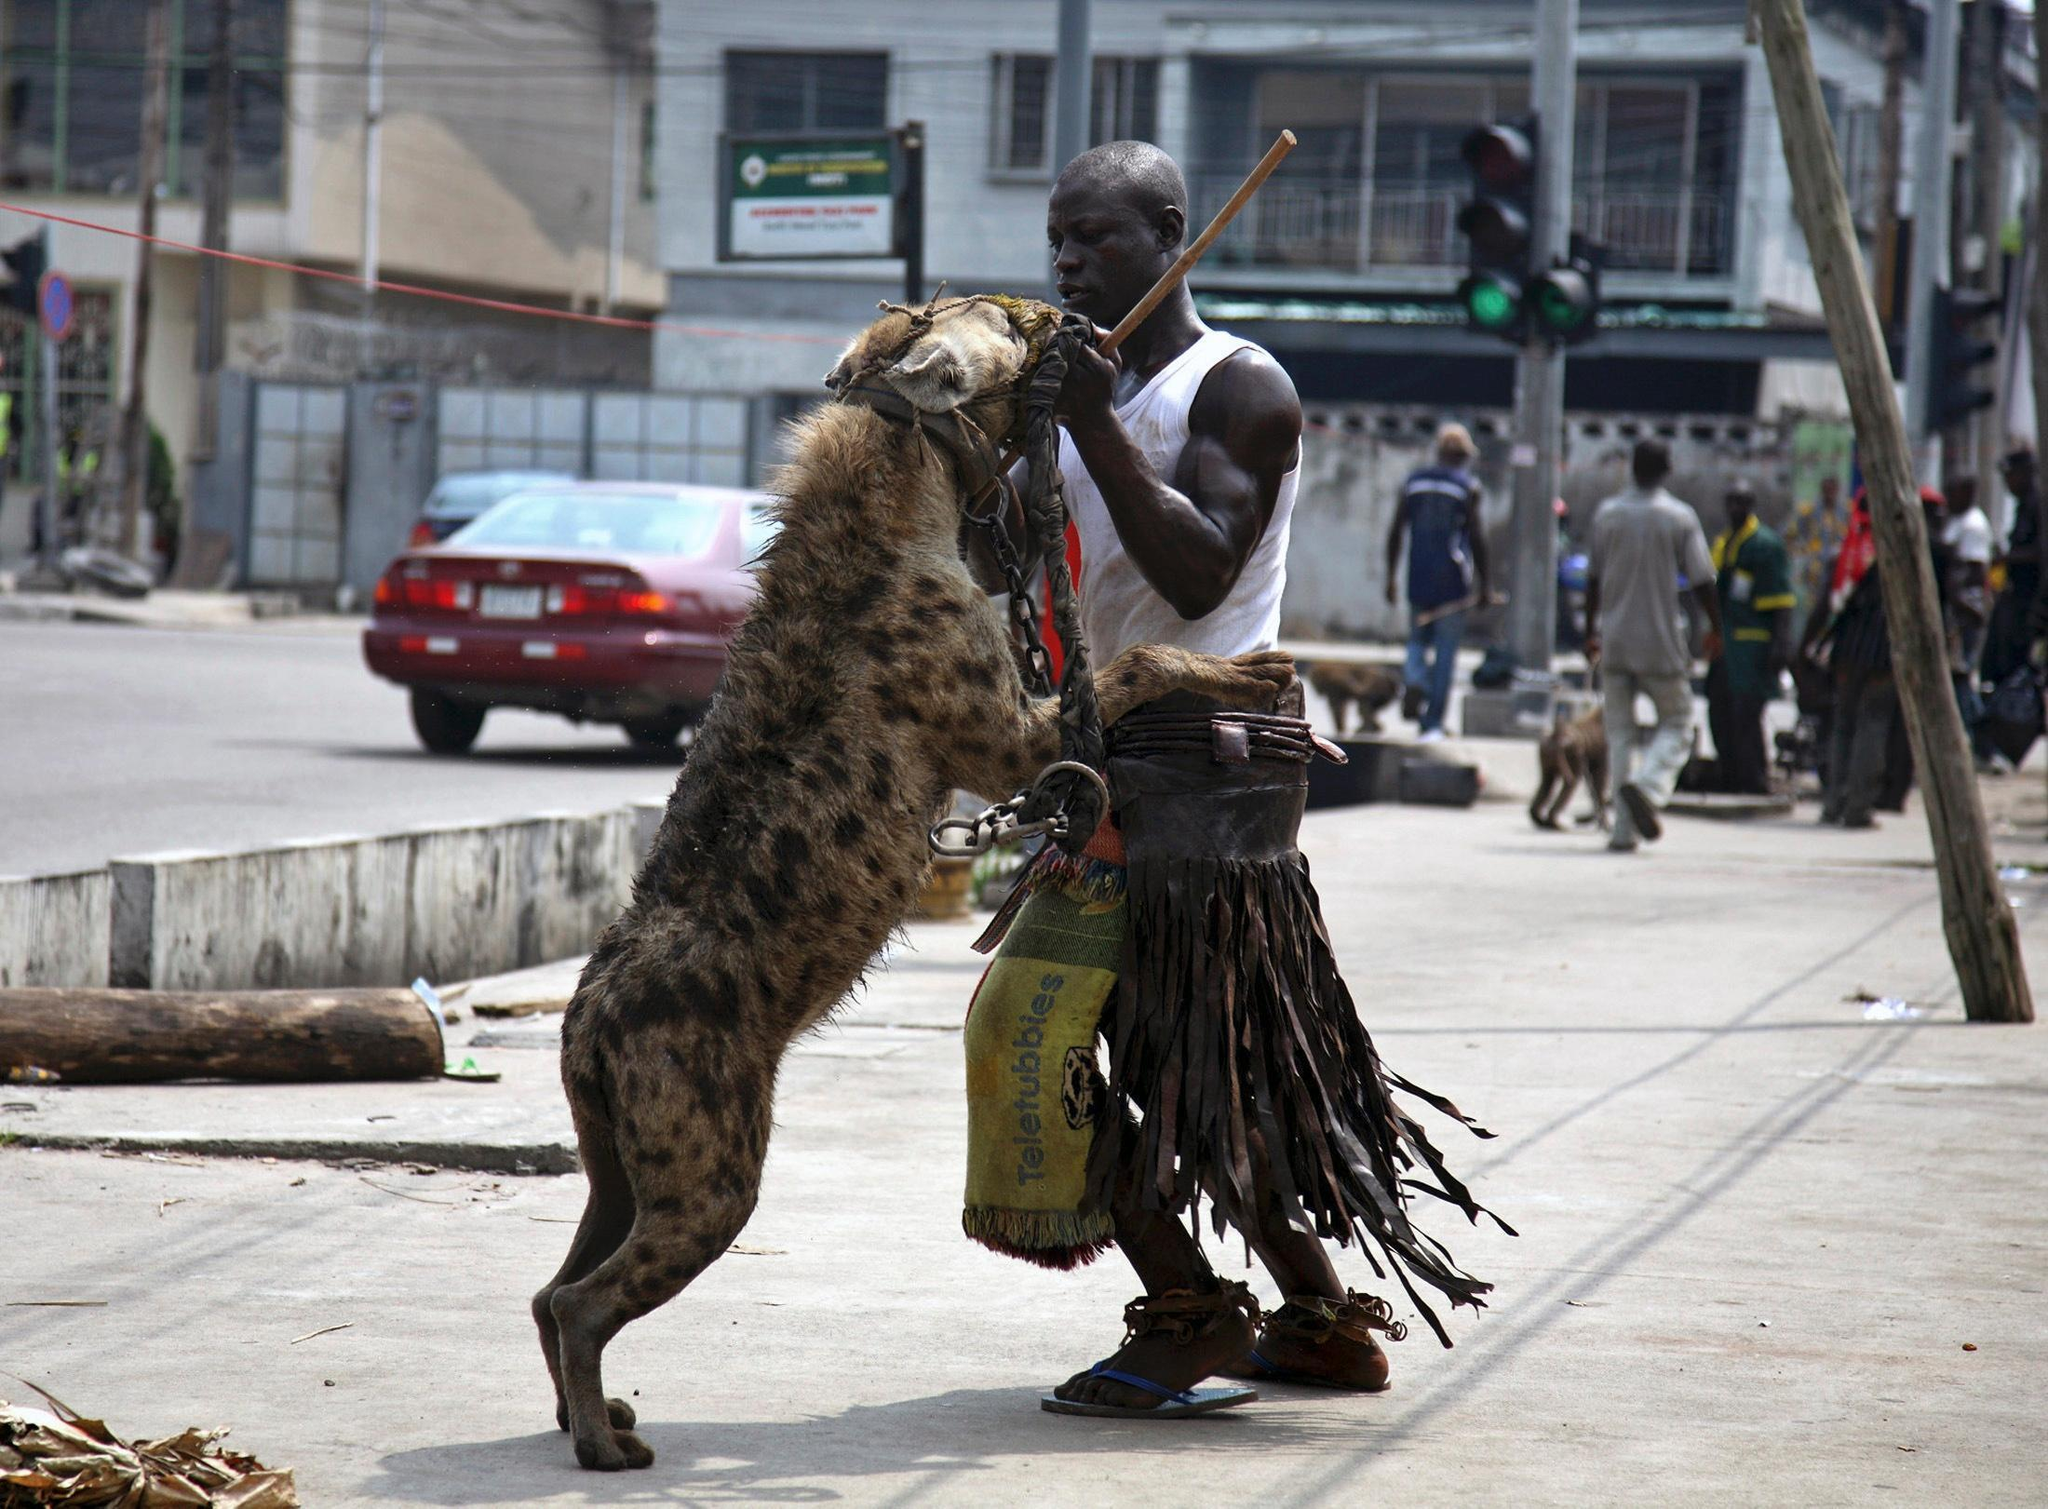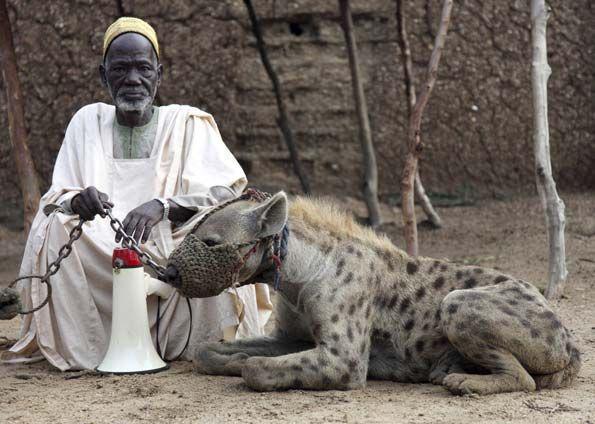The first image is the image on the left, the second image is the image on the right. For the images displayed, is the sentence "There are at least two people in the image on the right." factually correct? Answer yes or no. No. 